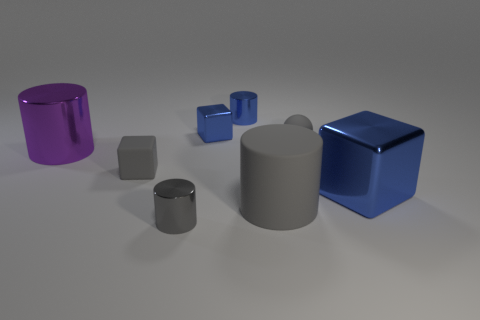Subtract 1 cylinders. How many cylinders are left? 3 Add 1 blue things. How many objects exist? 9 Subtract all blocks. How many objects are left? 5 Subtract 1 gray balls. How many objects are left? 7 Subtract all large purple things. Subtract all small metal cubes. How many objects are left? 6 Add 1 small spheres. How many small spheres are left? 2 Add 1 large purple spheres. How many large purple spheres exist? 1 